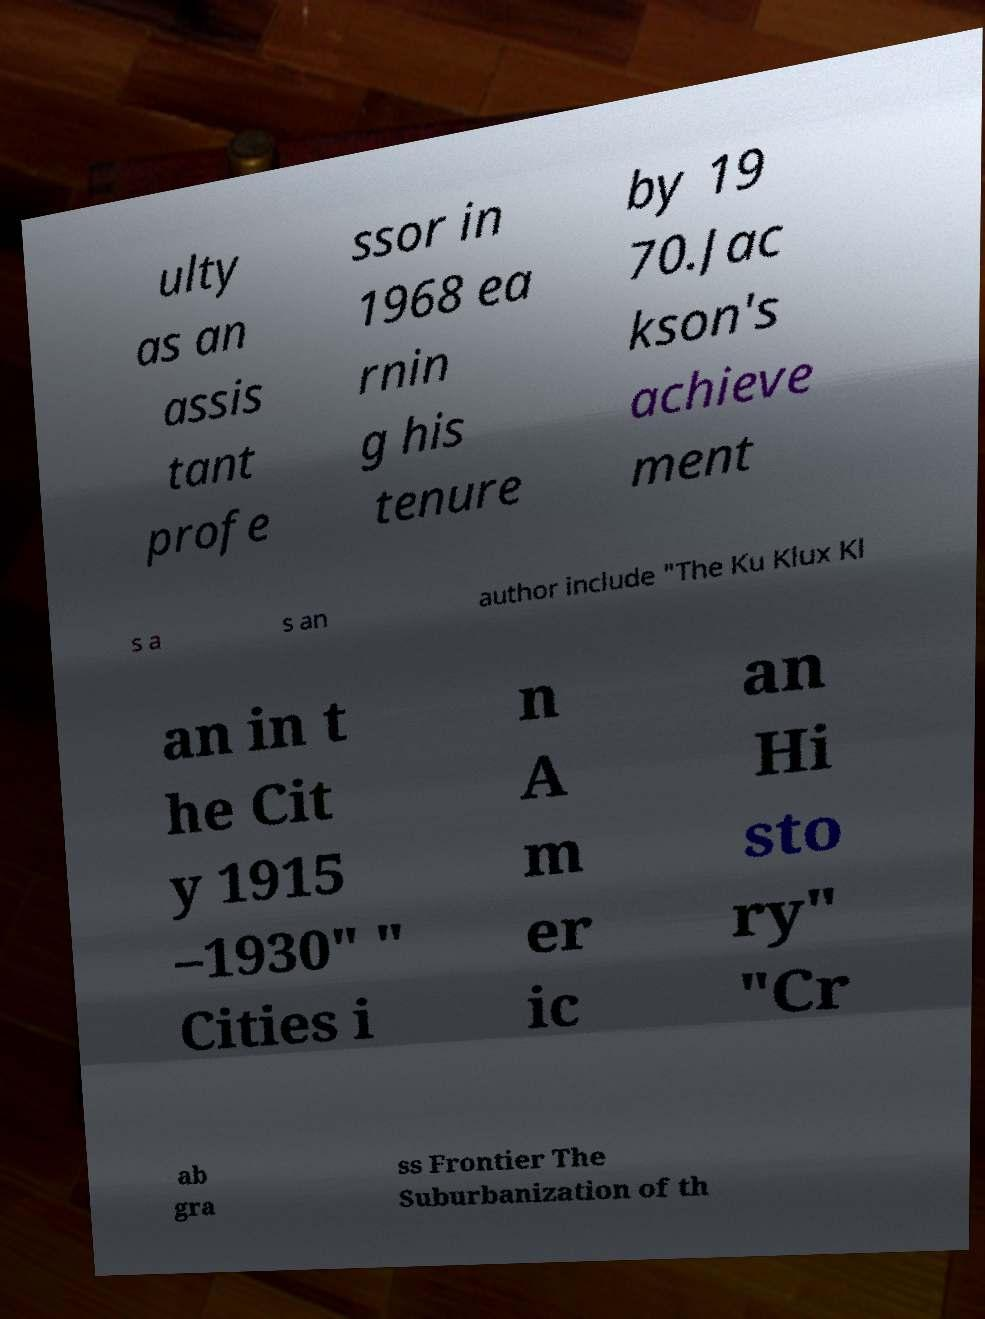Can you read and provide the text displayed in the image?This photo seems to have some interesting text. Can you extract and type it out for me? ulty as an assis tant profe ssor in 1968 ea rnin g his tenure by 19 70.Jac kson's achieve ment s a s an author include "The Ku Klux Kl an in t he Cit y 1915 –1930" " Cities i n A m er ic an Hi sto ry" "Cr ab gra ss Frontier The Suburbanization of th 